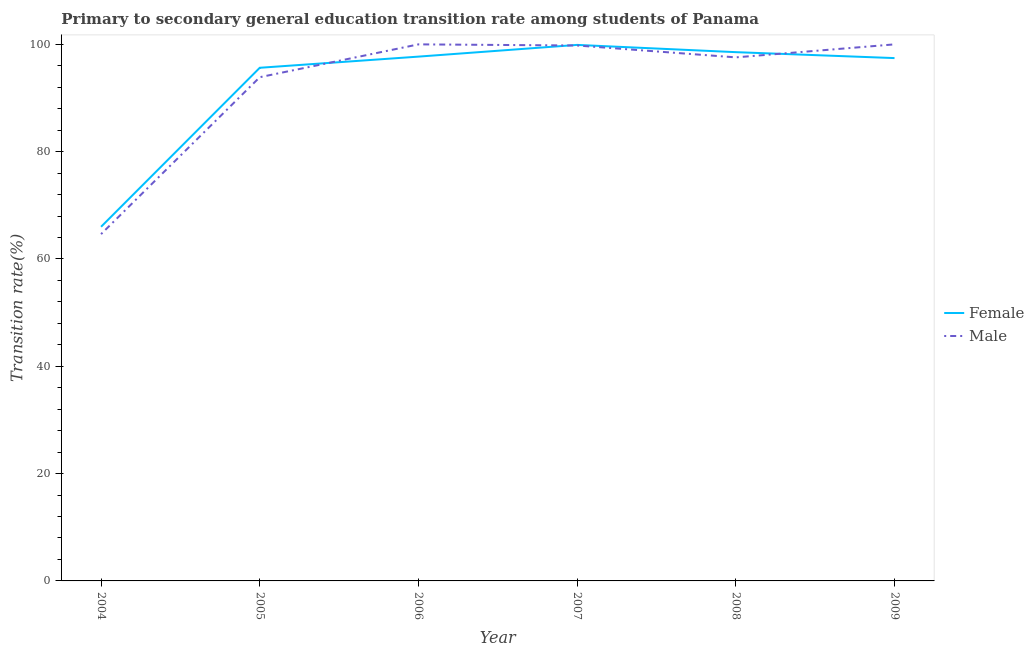Is the number of lines equal to the number of legend labels?
Keep it short and to the point. Yes. What is the transition rate among female students in 2009?
Keep it short and to the point. 97.44. Across all years, what is the maximum transition rate among female students?
Your answer should be very brief. 99.9. Across all years, what is the minimum transition rate among female students?
Provide a succinct answer. 66. In which year was the transition rate among female students maximum?
Make the answer very short. 2007. In which year was the transition rate among male students minimum?
Your response must be concise. 2004. What is the total transition rate among female students in the graph?
Your response must be concise. 555.24. What is the difference between the transition rate among male students in 2004 and that in 2006?
Your answer should be very brief. -35.37. What is the difference between the transition rate among female students in 2005 and the transition rate among male students in 2007?
Keep it short and to the point. -4.15. What is the average transition rate among male students per year?
Give a very brief answer. 92.65. In the year 2005, what is the difference between the transition rate among male students and transition rate among female students?
Offer a very short reply. -1.75. What is the ratio of the transition rate among female students in 2005 to that in 2008?
Your answer should be compact. 0.97. Is the difference between the transition rate among male students in 2005 and 2006 greater than the difference between the transition rate among female students in 2005 and 2006?
Offer a very short reply. No. What is the difference between the highest and the second highest transition rate among female students?
Ensure brevity in your answer.  1.35. What is the difference between the highest and the lowest transition rate among female students?
Give a very brief answer. 33.9. In how many years, is the transition rate among female students greater than the average transition rate among female students taken over all years?
Offer a terse response. 5. Is the sum of the transition rate among male students in 2004 and 2009 greater than the maximum transition rate among female students across all years?
Your answer should be compact. Yes. Does the transition rate among female students monotonically increase over the years?
Provide a short and direct response. No. Is the transition rate among male students strictly greater than the transition rate among female students over the years?
Provide a short and direct response. No. Is the transition rate among female students strictly less than the transition rate among male students over the years?
Ensure brevity in your answer.  No. How many lines are there?
Provide a short and direct response. 2. Are the values on the major ticks of Y-axis written in scientific E-notation?
Offer a terse response. No. Does the graph contain any zero values?
Ensure brevity in your answer.  No. How many legend labels are there?
Provide a short and direct response. 2. What is the title of the graph?
Provide a succinct answer. Primary to secondary general education transition rate among students of Panama. Does "Rural Population" appear as one of the legend labels in the graph?
Provide a succinct answer. No. What is the label or title of the Y-axis?
Your answer should be compact. Transition rate(%). What is the Transition rate(%) in Female in 2004?
Offer a very short reply. 66. What is the Transition rate(%) in Male in 2004?
Provide a succinct answer. 64.63. What is the Transition rate(%) of Female in 2005?
Ensure brevity in your answer.  95.64. What is the Transition rate(%) of Male in 2005?
Keep it short and to the point. 93.88. What is the Transition rate(%) of Female in 2006?
Offer a very short reply. 97.72. What is the Transition rate(%) in Female in 2007?
Ensure brevity in your answer.  99.9. What is the Transition rate(%) in Male in 2007?
Ensure brevity in your answer.  99.79. What is the Transition rate(%) of Female in 2008?
Provide a succinct answer. 98.55. What is the Transition rate(%) in Male in 2008?
Your answer should be compact. 97.58. What is the Transition rate(%) in Female in 2009?
Ensure brevity in your answer.  97.44. What is the Transition rate(%) in Male in 2009?
Your answer should be compact. 100. Across all years, what is the maximum Transition rate(%) of Female?
Provide a succinct answer. 99.9. Across all years, what is the maximum Transition rate(%) of Male?
Offer a terse response. 100. Across all years, what is the minimum Transition rate(%) in Female?
Make the answer very short. 66. Across all years, what is the minimum Transition rate(%) in Male?
Keep it short and to the point. 64.63. What is the total Transition rate(%) in Female in the graph?
Give a very brief answer. 555.24. What is the total Transition rate(%) in Male in the graph?
Make the answer very short. 555.88. What is the difference between the Transition rate(%) in Female in 2004 and that in 2005?
Give a very brief answer. -29.63. What is the difference between the Transition rate(%) of Male in 2004 and that in 2005?
Offer a very short reply. -29.25. What is the difference between the Transition rate(%) in Female in 2004 and that in 2006?
Your answer should be compact. -31.71. What is the difference between the Transition rate(%) of Male in 2004 and that in 2006?
Your response must be concise. -35.37. What is the difference between the Transition rate(%) in Female in 2004 and that in 2007?
Your response must be concise. -33.9. What is the difference between the Transition rate(%) of Male in 2004 and that in 2007?
Give a very brief answer. -35.15. What is the difference between the Transition rate(%) in Female in 2004 and that in 2008?
Offer a very short reply. -32.54. What is the difference between the Transition rate(%) in Male in 2004 and that in 2008?
Offer a very short reply. -32.94. What is the difference between the Transition rate(%) in Female in 2004 and that in 2009?
Provide a succinct answer. -31.44. What is the difference between the Transition rate(%) of Male in 2004 and that in 2009?
Make the answer very short. -35.37. What is the difference between the Transition rate(%) in Female in 2005 and that in 2006?
Provide a short and direct response. -2.08. What is the difference between the Transition rate(%) in Male in 2005 and that in 2006?
Give a very brief answer. -6.12. What is the difference between the Transition rate(%) in Female in 2005 and that in 2007?
Provide a succinct answer. -4.26. What is the difference between the Transition rate(%) of Male in 2005 and that in 2007?
Your answer should be compact. -5.91. What is the difference between the Transition rate(%) in Female in 2005 and that in 2008?
Your answer should be very brief. -2.91. What is the difference between the Transition rate(%) of Male in 2005 and that in 2008?
Your answer should be compact. -3.69. What is the difference between the Transition rate(%) of Female in 2005 and that in 2009?
Provide a short and direct response. -1.8. What is the difference between the Transition rate(%) of Male in 2005 and that in 2009?
Provide a succinct answer. -6.12. What is the difference between the Transition rate(%) in Female in 2006 and that in 2007?
Your response must be concise. -2.18. What is the difference between the Transition rate(%) in Male in 2006 and that in 2007?
Offer a terse response. 0.21. What is the difference between the Transition rate(%) in Female in 2006 and that in 2008?
Your response must be concise. -0.83. What is the difference between the Transition rate(%) in Male in 2006 and that in 2008?
Your answer should be very brief. 2.42. What is the difference between the Transition rate(%) in Female in 2006 and that in 2009?
Your answer should be very brief. 0.28. What is the difference between the Transition rate(%) of Male in 2006 and that in 2009?
Offer a very short reply. 0. What is the difference between the Transition rate(%) of Female in 2007 and that in 2008?
Make the answer very short. 1.35. What is the difference between the Transition rate(%) of Male in 2007 and that in 2008?
Your answer should be very brief. 2.21. What is the difference between the Transition rate(%) in Female in 2007 and that in 2009?
Keep it short and to the point. 2.46. What is the difference between the Transition rate(%) in Male in 2007 and that in 2009?
Make the answer very short. -0.21. What is the difference between the Transition rate(%) of Female in 2008 and that in 2009?
Offer a terse response. 1.11. What is the difference between the Transition rate(%) of Male in 2008 and that in 2009?
Keep it short and to the point. -2.42. What is the difference between the Transition rate(%) in Female in 2004 and the Transition rate(%) in Male in 2005?
Provide a succinct answer. -27.88. What is the difference between the Transition rate(%) in Female in 2004 and the Transition rate(%) in Male in 2006?
Ensure brevity in your answer.  -34. What is the difference between the Transition rate(%) in Female in 2004 and the Transition rate(%) in Male in 2007?
Offer a terse response. -33.78. What is the difference between the Transition rate(%) in Female in 2004 and the Transition rate(%) in Male in 2008?
Offer a very short reply. -31.57. What is the difference between the Transition rate(%) in Female in 2004 and the Transition rate(%) in Male in 2009?
Provide a succinct answer. -34. What is the difference between the Transition rate(%) of Female in 2005 and the Transition rate(%) of Male in 2006?
Keep it short and to the point. -4.36. What is the difference between the Transition rate(%) in Female in 2005 and the Transition rate(%) in Male in 2007?
Make the answer very short. -4.15. What is the difference between the Transition rate(%) of Female in 2005 and the Transition rate(%) of Male in 2008?
Provide a succinct answer. -1.94. What is the difference between the Transition rate(%) in Female in 2005 and the Transition rate(%) in Male in 2009?
Offer a very short reply. -4.36. What is the difference between the Transition rate(%) in Female in 2006 and the Transition rate(%) in Male in 2007?
Provide a short and direct response. -2.07. What is the difference between the Transition rate(%) in Female in 2006 and the Transition rate(%) in Male in 2008?
Your response must be concise. 0.14. What is the difference between the Transition rate(%) of Female in 2006 and the Transition rate(%) of Male in 2009?
Give a very brief answer. -2.28. What is the difference between the Transition rate(%) of Female in 2007 and the Transition rate(%) of Male in 2008?
Your answer should be compact. 2.32. What is the difference between the Transition rate(%) of Female in 2007 and the Transition rate(%) of Male in 2009?
Keep it short and to the point. -0.1. What is the difference between the Transition rate(%) of Female in 2008 and the Transition rate(%) of Male in 2009?
Provide a succinct answer. -1.45. What is the average Transition rate(%) in Female per year?
Your answer should be compact. 92.54. What is the average Transition rate(%) in Male per year?
Your answer should be compact. 92.65. In the year 2004, what is the difference between the Transition rate(%) in Female and Transition rate(%) in Male?
Offer a very short reply. 1.37. In the year 2005, what is the difference between the Transition rate(%) of Female and Transition rate(%) of Male?
Provide a succinct answer. 1.75. In the year 2006, what is the difference between the Transition rate(%) of Female and Transition rate(%) of Male?
Offer a terse response. -2.28. In the year 2007, what is the difference between the Transition rate(%) of Female and Transition rate(%) of Male?
Provide a succinct answer. 0.11. In the year 2008, what is the difference between the Transition rate(%) in Female and Transition rate(%) in Male?
Ensure brevity in your answer.  0.97. In the year 2009, what is the difference between the Transition rate(%) in Female and Transition rate(%) in Male?
Ensure brevity in your answer.  -2.56. What is the ratio of the Transition rate(%) of Female in 2004 to that in 2005?
Your response must be concise. 0.69. What is the ratio of the Transition rate(%) of Male in 2004 to that in 2005?
Offer a very short reply. 0.69. What is the ratio of the Transition rate(%) of Female in 2004 to that in 2006?
Keep it short and to the point. 0.68. What is the ratio of the Transition rate(%) in Male in 2004 to that in 2006?
Provide a succinct answer. 0.65. What is the ratio of the Transition rate(%) in Female in 2004 to that in 2007?
Provide a short and direct response. 0.66. What is the ratio of the Transition rate(%) in Male in 2004 to that in 2007?
Provide a succinct answer. 0.65. What is the ratio of the Transition rate(%) of Female in 2004 to that in 2008?
Your answer should be very brief. 0.67. What is the ratio of the Transition rate(%) in Male in 2004 to that in 2008?
Your answer should be very brief. 0.66. What is the ratio of the Transition rate(%) in Female in 2004 to that in 2009?
Provide a succinct answer. 0.68. What is the ratio of the Transition rate(%) in Male in 2004 to that in 2009?
Keep it short and to the point. 0.65. What is the ratio of the Transition rate(%) of Female in 2005 to that in 2006?
Offer a very short reply. 0.98. What is the ratio of the Transition rate(%) of Male in 2005 to that in 2006?
Ensure brevity in your answer.  0.94. What is the ratio of the Transition rate(%) of Female in 2005 to that in 2007?
Your answer should be very brief. 0.96. What is the ratio of the Transition rate(%) in Male in 2005 to that in 2007?
Your response must be concise. 0.94. What is the ratio of the Transition rate(%) in Female in 2005 to that in 2008?
Make the answer very short. 0.97. What is the ratio of the Transition rate(%) in Male in 2005 to that in 2008?
Your answer should be very brief. 0.96. What is the ratio of the Transition rate(%) of Female in 2005 to that in 2009?
Provide a short and direct response. 0.98. What is the ratio of the Transition rate(%) of Male in 2005 to that in 2009?
Provide a short and direct response. 0.94. What is the ratio of the Transition rate(%) of Female in 2006 to that in 2007?
Provide a short and direct response. 0.98. What is the ratio of the Transition rate(%) of Female in 2006 to that in 2008?
Your response must be concise. 0.99. What is the ratio of the Transition rate(%) in Male in 2006 to that in 2008?
Keep it short and to the point. 1.02. What is the ratio of the Transition rate(%) in Female in 2006 to that in 2009?
Make the answer very short. 1. What is the ratio of the Transition rate(%) in Male in 2006 to that in 2009?
Your response must be concise. 1. What is the ratio of the Transition rate(%) of Female in 2007 to that in 2008?
Provide a succinct answer. 1.01. What is the ratio of the Transition rate(%) in Male in 2007 to that in 2008?
Your response must be concise. 1.02. What is the ratio of the Transition rate(%) of Female in 2007 to that in 2009?
Your response must be concise. 1.03. What is the ratio of the Transition rate(%) of Female in 2008 to that in 2009?
Provide a short and direct response. 1.01. What is the ratio of the Transition rate(%) in Male in 2008 to that in 2009?
Your answer should be very brief. 0.98. What is the difference between the highest and the second highest Transition rate(%) in Female?
Keep it short and to the point. 1.35. What is the difference between the highest and the lowest Transition rate(%) of Female?
Your answer should be compact. 33.9. What is the difference between the highest and the lowest Transition rate(%) of Male?
Make the answer very short. 35.37. 